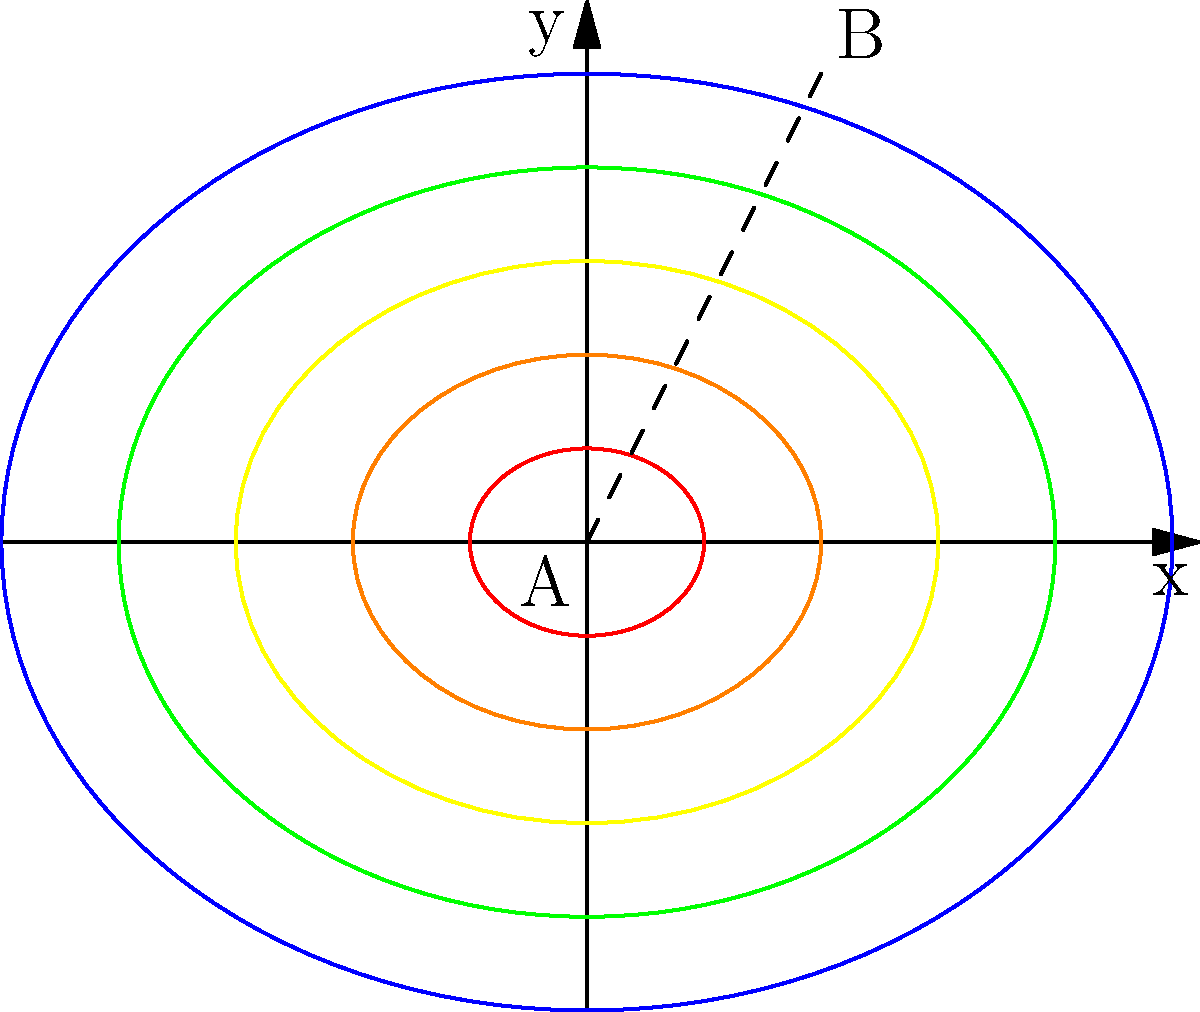Based on the topographic contour map shown, which represents a hill with concentric contour lines at 100-foot intervals, calculate the average slope along the line AB. How does this slope relate to potential landslide risk in the area? To solve this problem and assess the landslide risk, we'll follow these steps:

1. Determine the horizontal distance:
   The line AB spans 2 units on the x-axis and 4 units on the y-axis.
   Horizontal distance = $\sqrt{2^2 + 4^2} = \sqrt{20} \approx 4.47$ units

2. Calculate the vertical rise:
   Point A is at the 100-foot contour.
   Point B is at the 500-foot contour.
   Vertical rise = 500 - 100 = 400 feet

3. Calculate the slope:
   Slope = rise / run
   Slope = 400 feet / (4.47 * 100 feet/unit) = 0.894 or 89.4%

4. Convert to degrees:
   Angle = $\arctan(0.894) \approx 41.8°$

5. Assess landslide risk:
   Slopes greater than 30-35° are generally considered high-risk for landslides.
   The calculated slope of 41.8° indicates a very high landslide risk.

Factors contributing to high landslide risk:
- Steep slope (> 30°)
- Closely spaced contour lines indicating rapid elevation change
- Potential for water accumulation and soil saturation
- Possibility of unstable soil or rock formations

GIS analysis would involve creating a slope map from the contour data, identifying areas with slopes > 30°, and combining this with other risk factors such as soil type, vegetation cover, and precipitation data to create a comprehensive landslide hazard map.
Answer: 89.4% slope (41.8°); high landslide risk due to steep gradient exceeding 30° 